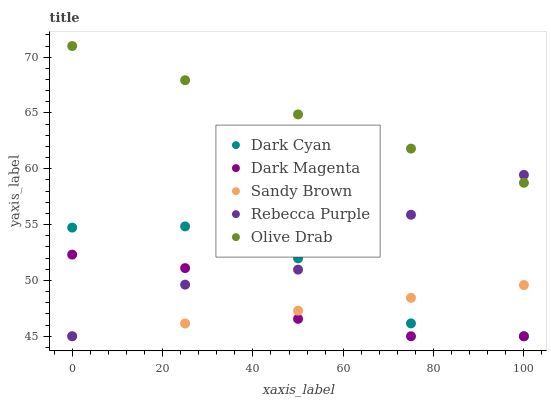Does Sandy Brown have the minimum area under the curve?
Answer yes or no. Yes. Does Olive Drab have the maximum area under the curve?
Answer yes or no. Yes. Does Dark Magenta have the minimum area under the curve?
Answer yes or no. No. Does Dark Magenta have the maximum area under the curve?
Answer yes or no. No. Is Olive Drab the smoothest?
Answer yes or no. Yes. Is Dark Cyan the roughest?
Answer yes or no. Yes. Is Sandy Brown the smoothest?
Answer yes or no. No. Is Sandy Brown the roughest?
Answer yes or no. No. Does Dark Cyan have the lowest value?
Answer yes or no. Yes. Does Olive Drab have the lowest value?
Answer yes or no. No. Does Olive Drab have the highest value?
Answer yes or no. Yes. Does Dark Magenta have the highest value?
Answer yes or no. No. Is Dark Magenta less than Olive Drab?
Answer yes or no. Yes. Is Olive Drab greater than Dark Magenta?
Answer yes or no. Yes. Does Dark Magenta intersect Dark Cyan?
Answer yes or no. Yes. Is Dark Magenta less than Dark Cyan?
Answer yes or no. No. Is Dark Magenta greater than Dark Cyan?
Answer yes or no. No. Does Dark Magenta intersect Olive Drab?
Answer yes or no. No. 